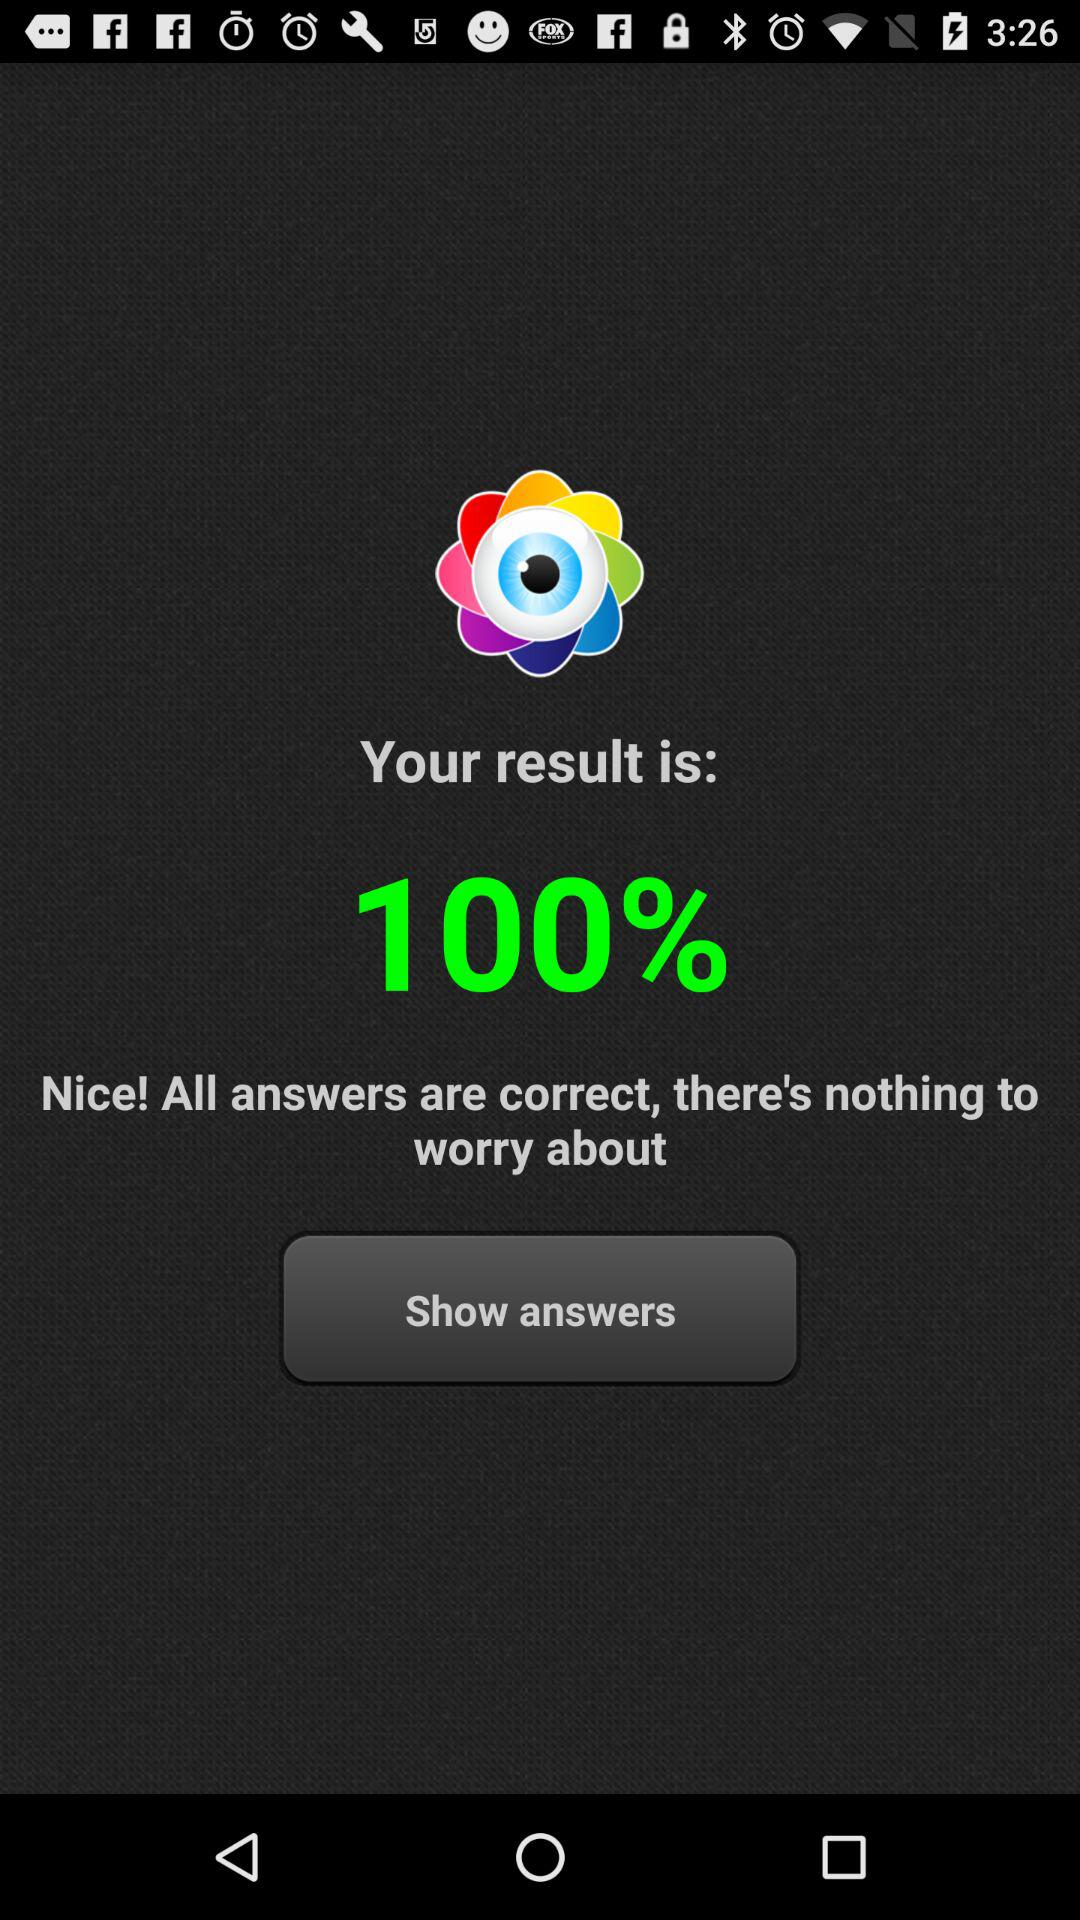What is the result? The result is 100%. 